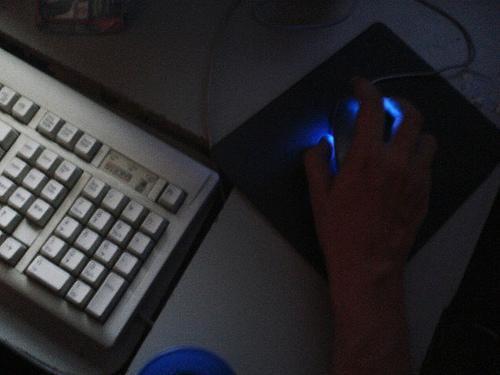How many colors can be seen on the keyboard?
Give a very brief answer. 2. How many times has the blue cord been wrapped?
Give a very brief answer. 1. How many color lights do you see?
Give a very brief answer. 1. How many mice are visible?
Give a very brief answer. 1. How many chairs are empty?
Give a very brief answer. 0. 